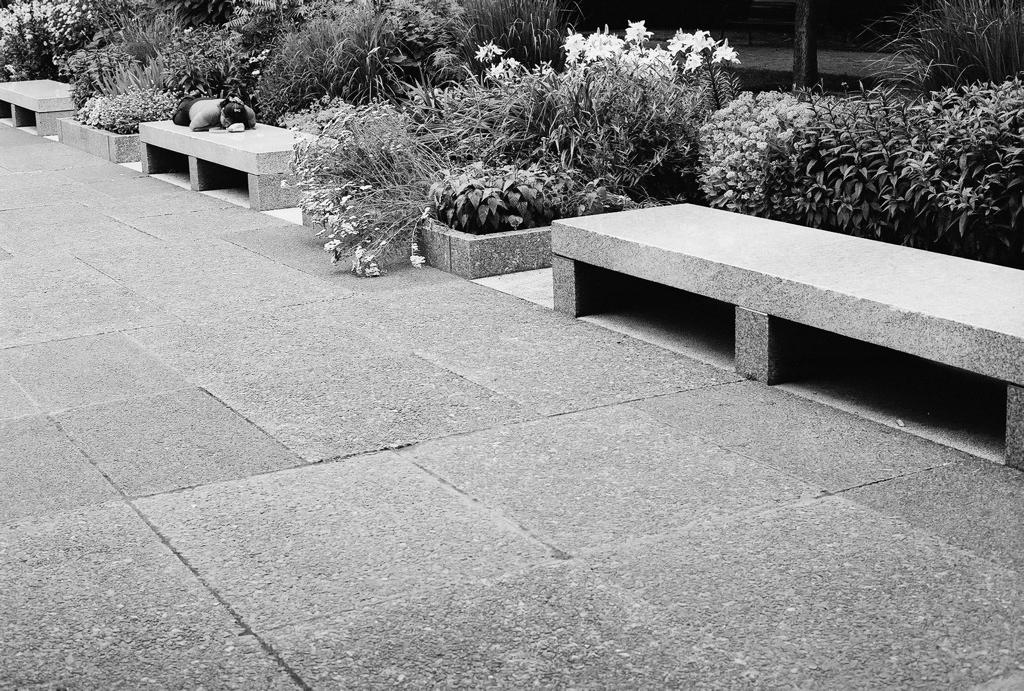Where was the image taken? The image was taken in a garden. What is at the bottom of the image? There is a floor at the bottom of the image. What type of benches can be seen in the image? There are benches made of rocks to the right. What kind of vegetation is present in the image? Plants are present in the image. What specific type of plant can be seen in the image? Flowers are visible in the image. What type of rice is being used to grip the flowers in the image? There is no rice or gripping action present in the image; it features flowers in a garden setting. 